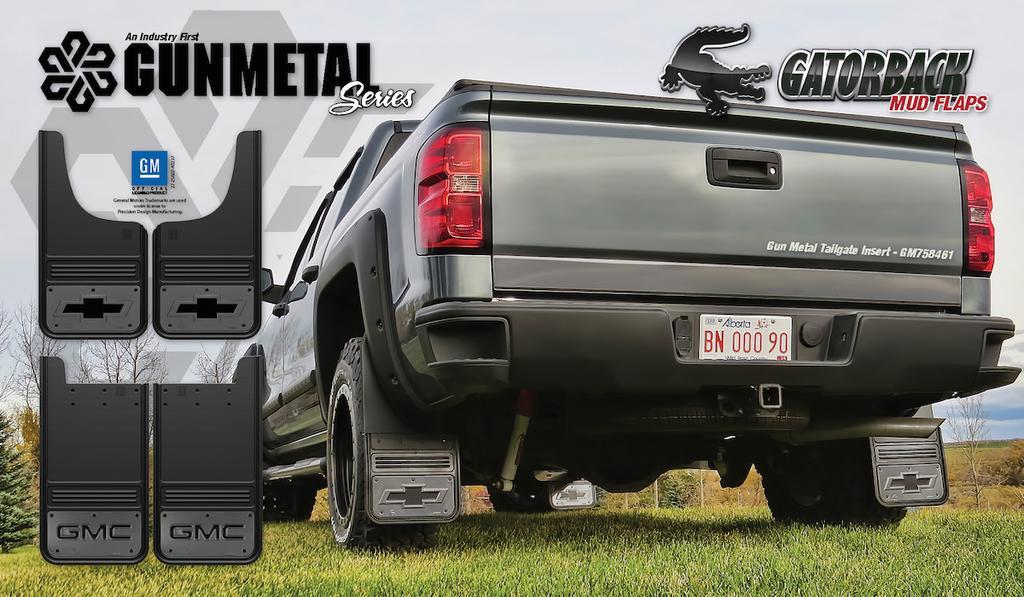How would you summarize this image in a sentence or two? In this picture we can silver van is parked on the grass. On the top we can see the "Gunmetal series" is written. 